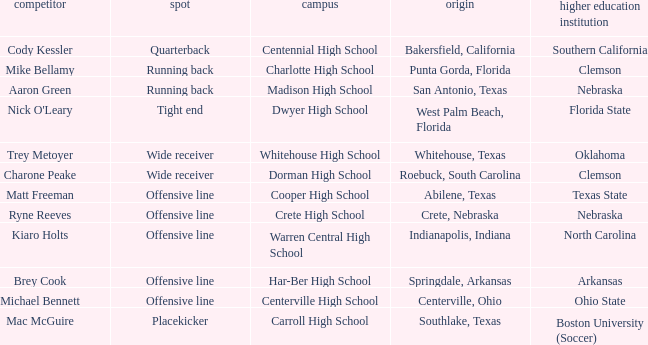What college did the placekicker go to? Boston University (Soccer). 